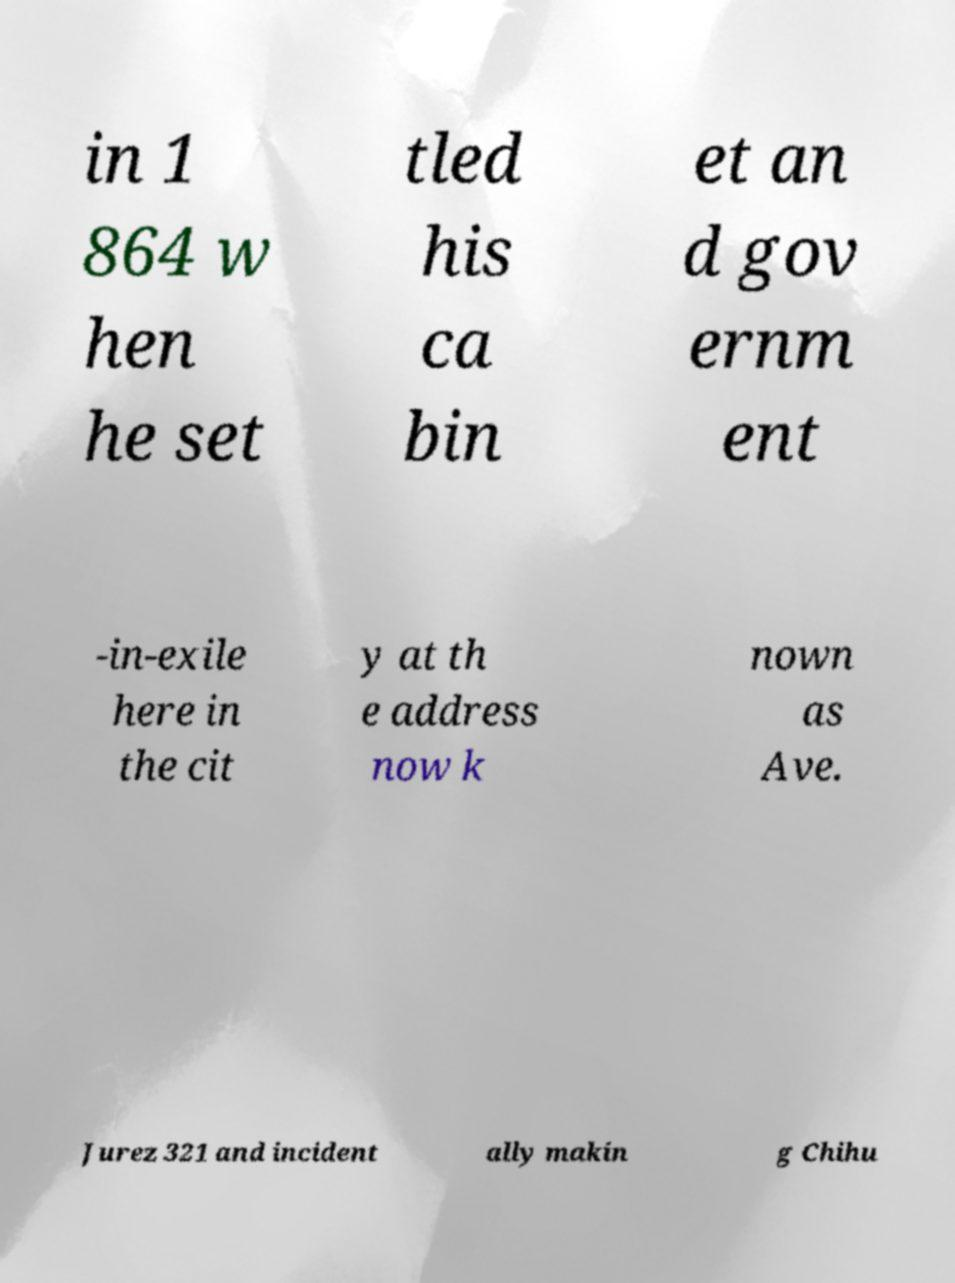What messages or text are displayed in this image? I need them in a readable, typed format. in 1 864 w hen he set tled his ca bin et an d gov ernm ent -in-exile here in the cit y at th e address now k nown as Ave. Jurez 321 and incident ally makin g Chihu 